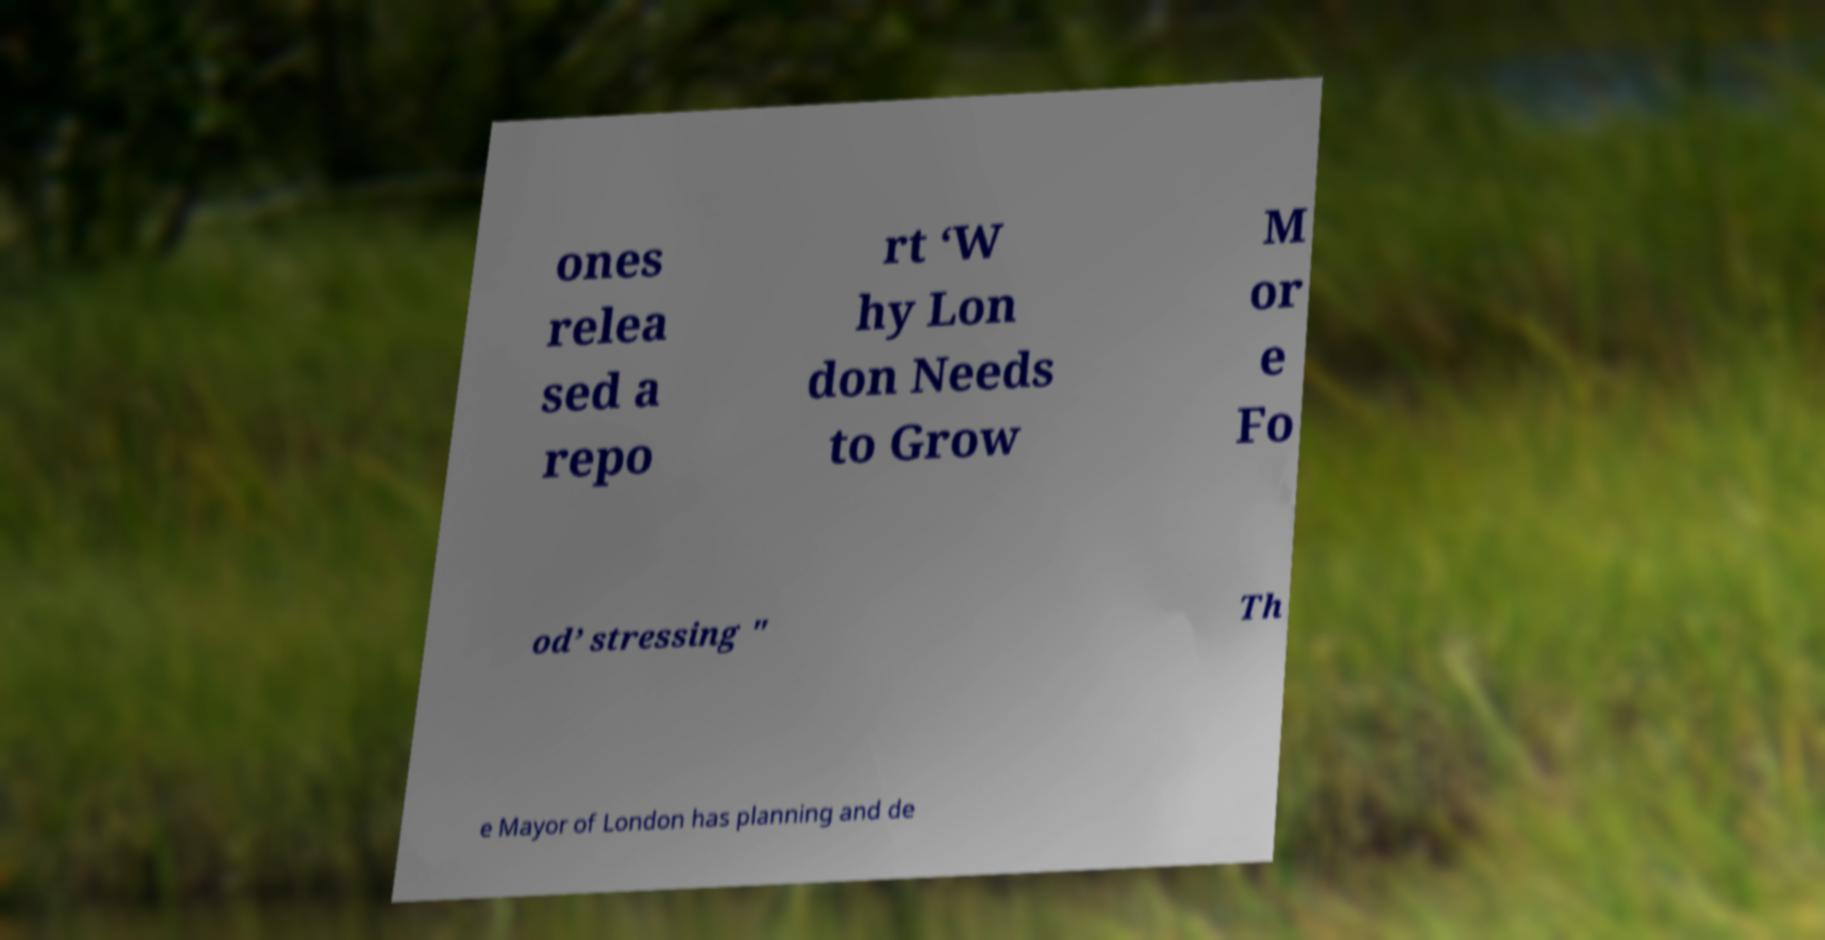What messages or text are displayed in this image? I need them in a readable, typed format. ones relea sed a repo rt ‘W hy Lon don Needs to Grow M or e Fo od’ stressing " Th e Mayor of London has planning and de 